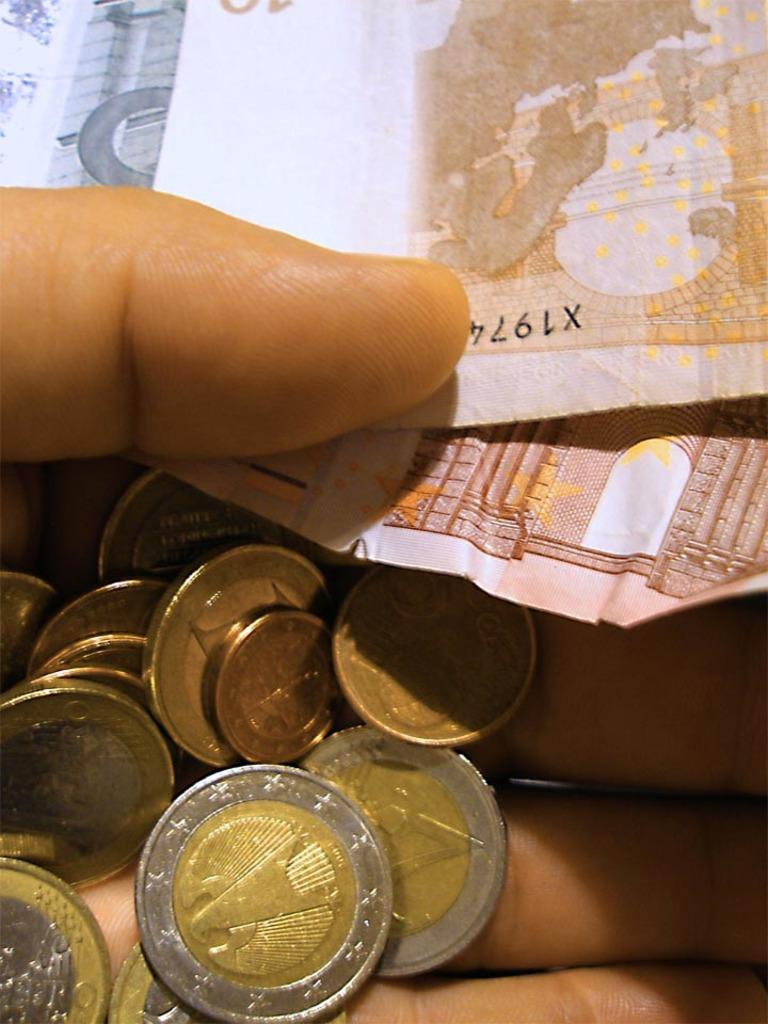<image>
Present a compact description of the photo's key features. A hand is holding coins and a bill with the serial number starting X1974 visible on one end. 